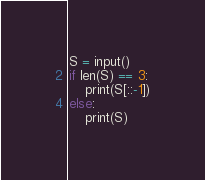<code> <loc_0><loc_0><loc_500><loc_500><_Python_>S = input()
if len(S) == 3:
    print(S[::-1])
else:
    print(S)</code> 